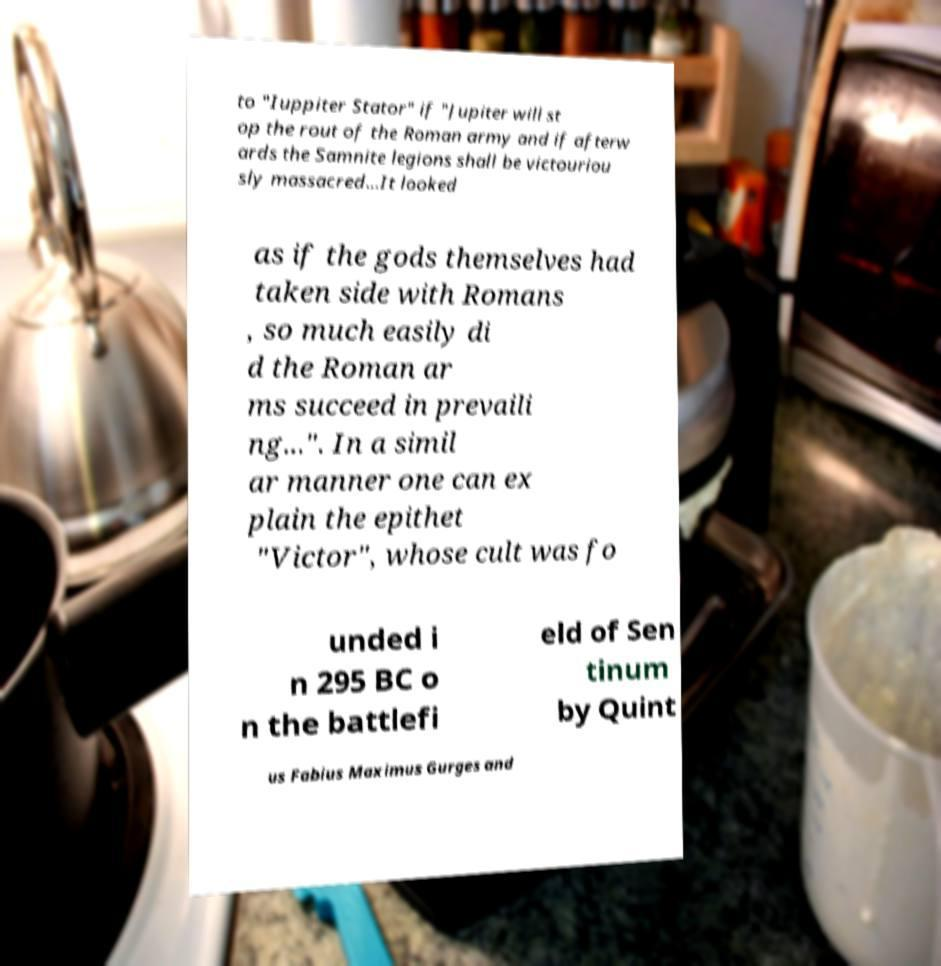There's text embedded in this image that I need extracted. Can you transcribe it verbatim? to "Iuppiter Stator" if "Jupiter will st op the rout of the Roman army and if afterw ards the Samnite legions shall be victouriou sly massacred...It looked as if the gods themselves had taken side with Romans , so much easily di d the Roman ar ms succeed in prevaili ng...". In a simil ar manner one can ex plain the epithet "Victor", whose cult was fo unded i n 295 BC o n the battlefi eld of Sen tinum by Quint us Fabius Maximus Gurges and 